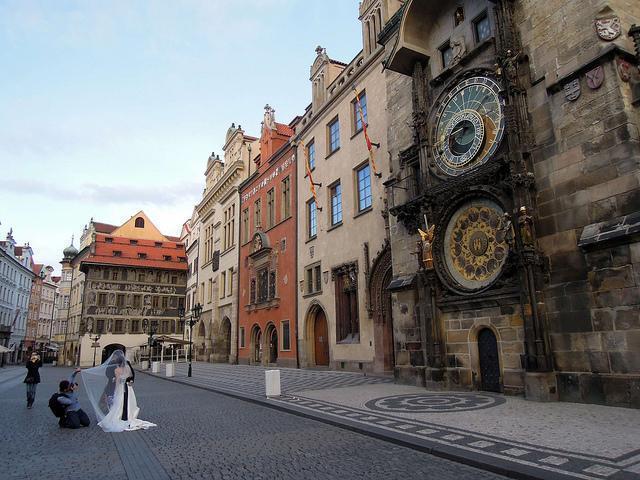What is the woman wearing?
Choose the right answer from the provided options to respond to the question.
Options: Backpack, wedding dress, bicycle helmet, crown. Wedding dress. What occasion is now photographed underneath the clock faces?
Choose the right answer from the provided options to respond to the question.
Options: Sale, realty, insurance, marriage. Marriage. 